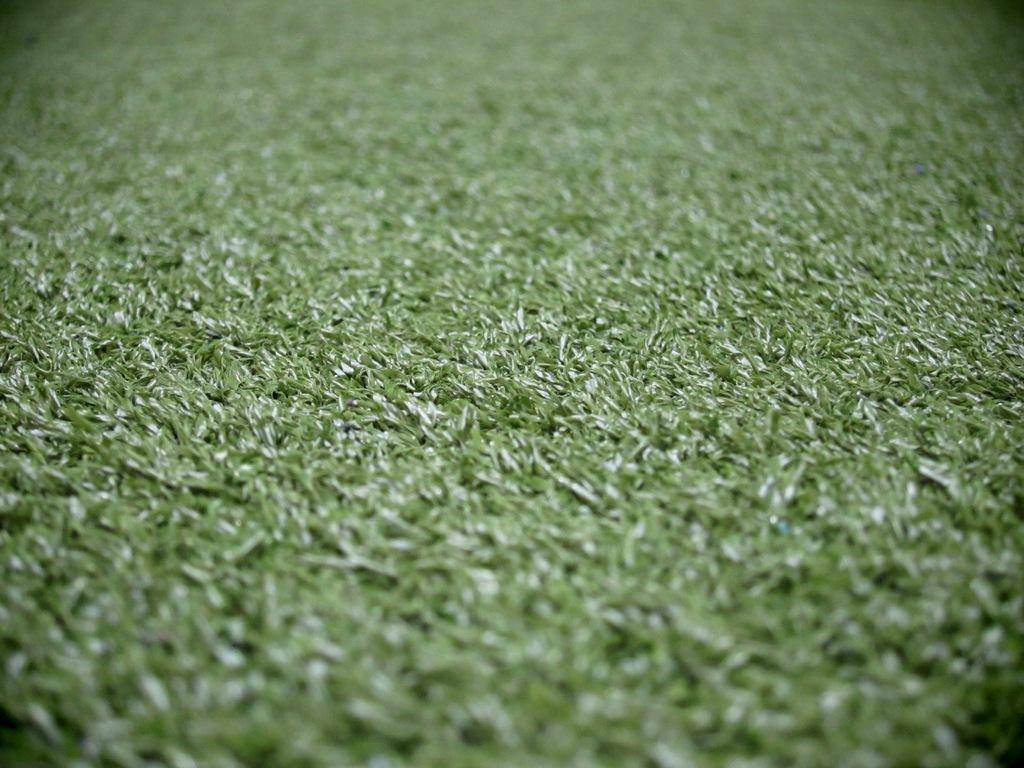What type of vegetation is present in the image? The image contains grass. Can you describe the color or texture of the grass? The provided facts do not include information about the color or texture of the grass. Is the grass the only element present in the image? The provided facts do not indicate whether there are other elements present in the image. How many drawers are visible in the image? There are no drawers present in the image, as it only contains grass. What type of winter clothing can be seen on the grass in the image? There is no winter clothing present in the image, as it only contains grass. 